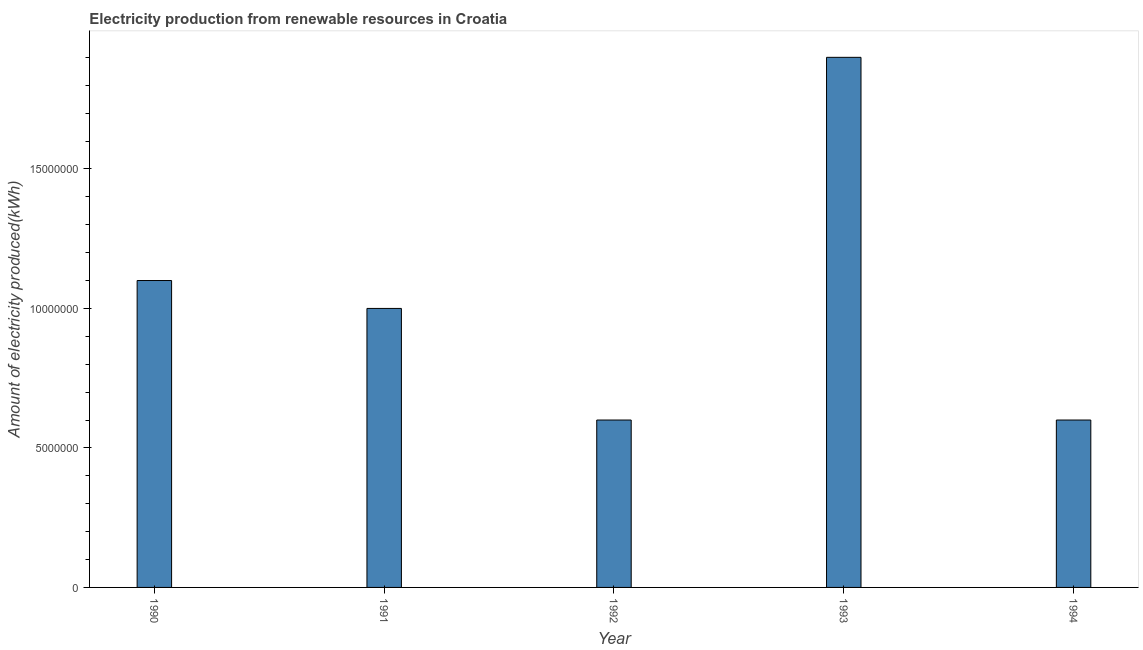Does the graph contain any zero values?
Your answer should be very brief. No. Does the graph contain grids?
Your response must be concise. No. What is the title of the graph?
Offer a terse response. Electricity production from renewable resources in Croatia. What is the label or title of the X-axis?
Offer a very short reply. Year. What is the label or title of the Y-axis?
Your answer should be compact. Amount of electricity produced(kWh). What is the amount of electricity produced in 1990?
Your answer should be very brief. 1.10e+07. Across all years, what is the maximum amount of electricity produced?
Your answer should be compact. 1.90e+07. Across all years, what is the minimum amount of electricity produced?
Provide a short and direct response. 6.00e+06. What is the sum of the amount of electricity produced?
Ensure brevity in your answer.  5.20e+07. What is the difference between the amount of electricity produced in 1990 and 1994?
Provide a succinct answer. 5.00e+06. What is the average amount of electricity produced per year?
Ensure brevity in your answer.  1.04e+07. In how many years, is the amount of electricity produced greater than 16000000 kWh?
Your answer should be compact. 1. Do a majority of the years between 1991 and 1993 (inclusive) have amount of electricity produced greater than 4000000 kWh?
Offer a terse response. Yes. What is the ratio of the amount of electricity produced in 1991 to that in 1992?
Offer a terse response. 1.67. What is the difference between the highest and the second highest amount of electricity produced?
Offer a terse response. 8.00e+06. What is the difference between the highest and the lowest amount of electricity produced?
Provide a short and direct response. 1.30e+07. In how many years, is the amount of electricity produced greater than the average amount of electricity produced taken over all years?
Give a very brief answer. 2. Are all the bars in the graph horizontal?
Your response must be concise. No. What is the difference between two consecutive major ticks on the Y-axis?
Offer a very short reply. 5.00e+06. What is the Amount of electricity produced(kWh) in 1990?
Give a very brief answer. 1.10e+07. What is the Amount of electricity produced(kWh) of 1992?
Provide a succinct answer. 6.00e+06. What is the Amount of electricity produced(kWh) of 1993?
Make the answer very short. 1.90e+07. What is the Amount of electricity produced(kWh) of 1994?
Your answer should be compact. 6.00e+06. What is the difference between the Amount of electricity produced(kWh) in 1990 and 1991?
Provide a succinct answer. 1.00e+06. What is the difference between the Amount of electricity produced(kWh) in 1990 and 1992?
Your answer should be very brief. 5.00e+06. What is the difference between the Amount of electricity produced(kWh) in 1990 and 1993?
Provide a short and direct response. -8.00e+06. What is the difference between the Amount of electricity produced(kWh) in 1991 and 1992?
Provide a succinct answer. 4.00e+06. What is the difference between the Amount of electricity produced(kWh) in 1991 and 1993?
Make the answer very short. -9.00e+06. What is the difference between the Amount of electricity produced(kWh) in 1991 and 1994?
Provide a short and direct response. 4.00e+06. What is the difference between the Amount of electricity produced(kWh) in 1992 and 1993?
Offer a terse response. -1.30e+07. What is the difference between the Amount of electricity produced(kWh) in 1992 and 1994?
Offer a very short reply. 0. What is the difference between the Amount of electricity produced(kWh) in 1993 and 1994?
Ensure brevity in your answer.  1.30e+07. What is the ratio of the Amount of electricity produced(kWh) in 1990 to that in 1991?
Give a very brief answer. 1.1. What is the ratio of the Amount of electricity produced(kWh) in 1990 to that in 1992?
Provide a succinct answer. 1.83. What is the ratio of the Amount of electricity produced(kWh) in 1990 to that in 1993?
Offer a terse response. 0.58. What is the ratio of the Amount of electricity produced(kWh) in 1990 to that in 1994?
Offer a terse response. 1.83. What is the ratio of the Amount of electricity produced(kWh) in 1991 to that in 1992?
Your answer should be very brief. 1.67. What is the ratio of the Amount of electricity produced(kWh) in 1991 to that in 1993?
Make the answer very short. 0.53. What is the ratio of the Amount of electricity produced(kWh) in 1991 to that in 1994?
Your answer should be compact. 1.67. What is the ratio of the Amount of electricity produced(kWh) in 1992 to that in 1993?
Offer a terse response. 0.32. What is the ratio of the Amount of electricity produced(kWh) in 1993 to that in 1994?
Your answer should be very brief. 3.17. 